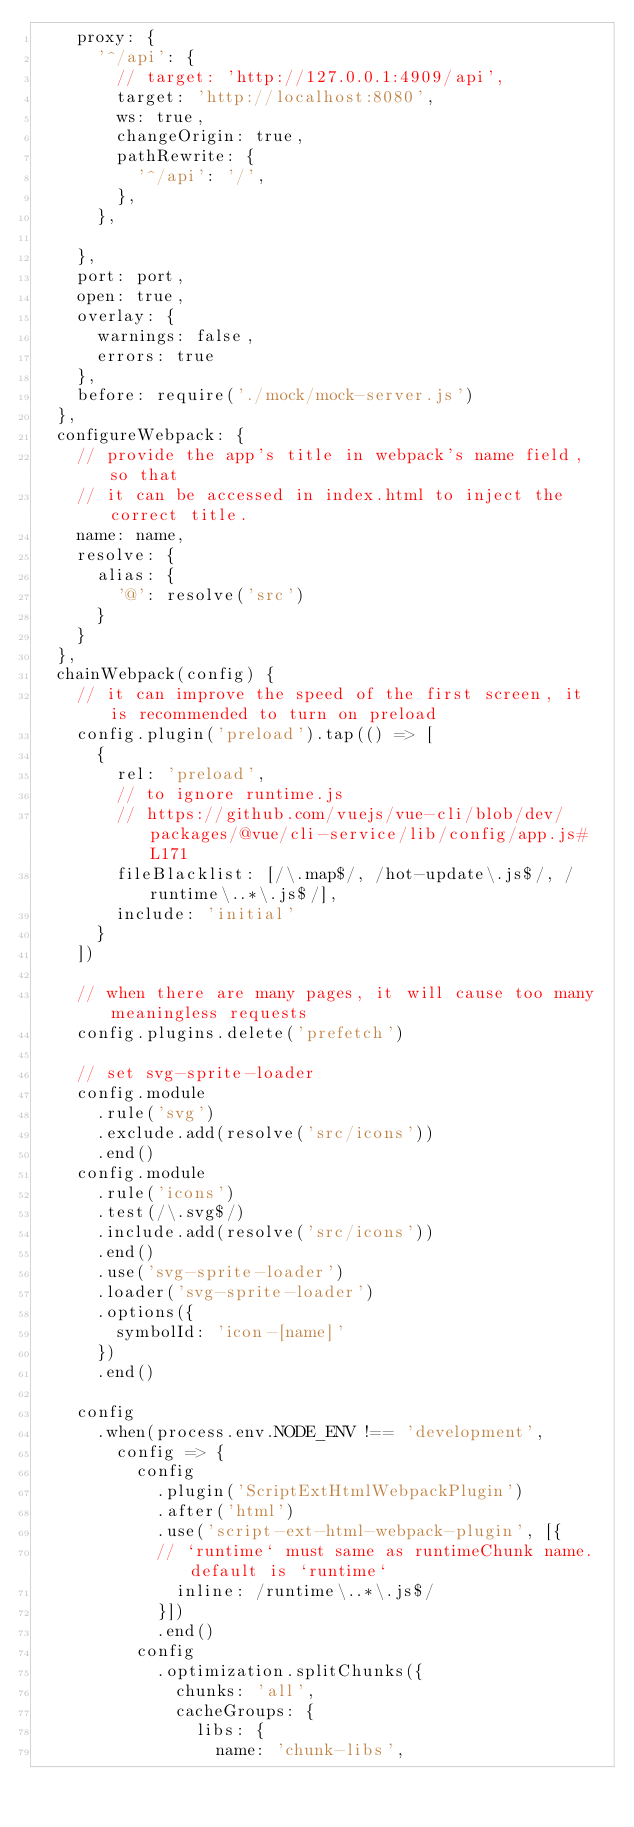<code> <loc_0><loc_0><loc_500><loc_500><_JavaScript_>    proxy: {
      '^/api': {
        // target: 'http://127.0.0.1:4909/api',
        target: 'http://localhost:8080',
        ws: true,
        changeOrigin: true,
        pathRewrite: {
          '^/api': '/',
        },
      },
      
    },
    port: port,
    open: true,
    overlay: {
      warnings: false,
      errors: true
    },
    before: require('./mock/mock-server.js')
  },
  configureWebpack: {
    // provide the app's title in webpack's name field, so that
    // it can be accessed in index.html to inject the correct title.
    name: name,
    resolve: {
      alias: {
        '@': resolve('src')
      }
    }
  },
  chainWebpack(config) {
    // it can improve the speed of the first screen, it is recommended to turn on preload
    config.plugin('preload').tap(() => [
      {
        rel: 'preload',
        // to ignore runtime.js
        // https://github.com/vuejs/vue-cli/blob/dev/packages/@vue/cli-service/lib/config/app.js#L171
        fileBlacklist: [/\.map$/, /hot-update\.js$/, /runtime\..*\.js$/],
        include: 'initial'
      }
    ])

    // when there are many pages, it will cause too many meaningless requests
    config.plugins.delete('prefetch')

    // set svg-sprite-loader
    config.module
      .rule('svg')
      .exclude.add(resolve('src/icons'))
      .end()
    config.module
      .rule('icons')
      .test(/\.svg$/)
      .include.add(resolve('src/icons'))
      .end()
      .use('svg-sprite-loader')
      .loader('svg-sprite-loader')
      .options({
        symbolId: 'icon-[name]'
      })
      .end()

    config
      .when(process.env.NODE_ENV !== 'development',
        config => {
          config
            .plugin('ScriptExtHtmlWebpackPlugin')
            .after('html')
            .use('script-ext-html-webpack-plugin', [{
            // `runtime` must same as runtimeChunk name. default is `runtime`
              inline: /runtime\..*\.js$/
            }])
            .end()
          config
            .optimization.splitChunks({
              chunks: 'all',
              cacheGroups: {
                libs: {
                  name: 'chunk-libs',</code> 